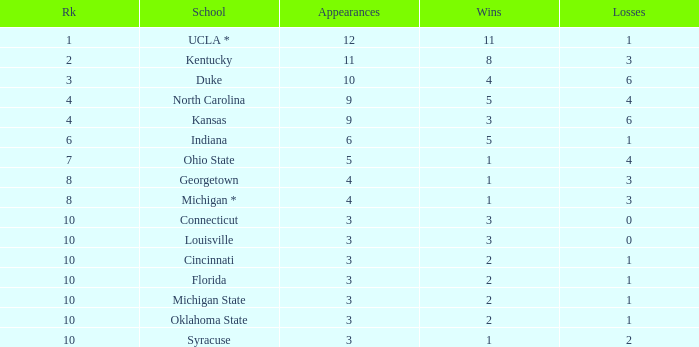Tell me the average Rank for lossess less than 6 and wins less than 11 for michigan state 10.0. 